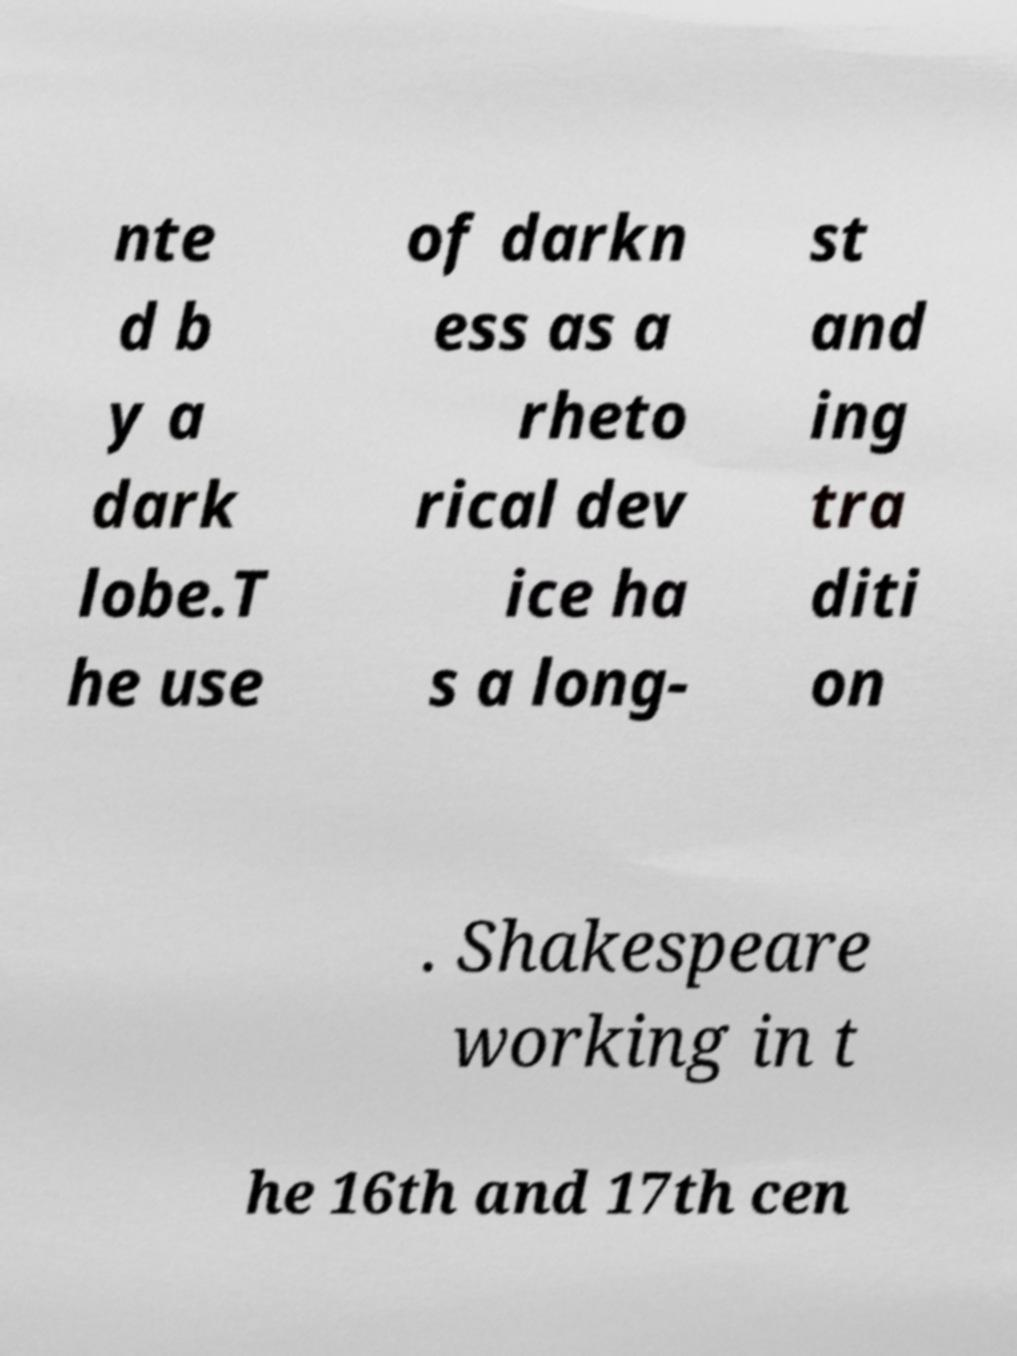For documentation purposes, I need the text within this image transcribed. Could you provide that? nte d b y a dark lobe.T he use of darkn ess as a rheto rical dev ice ha s a long- st and ing tra diti on . Shakespeare working in t he 16th and 17th cen 